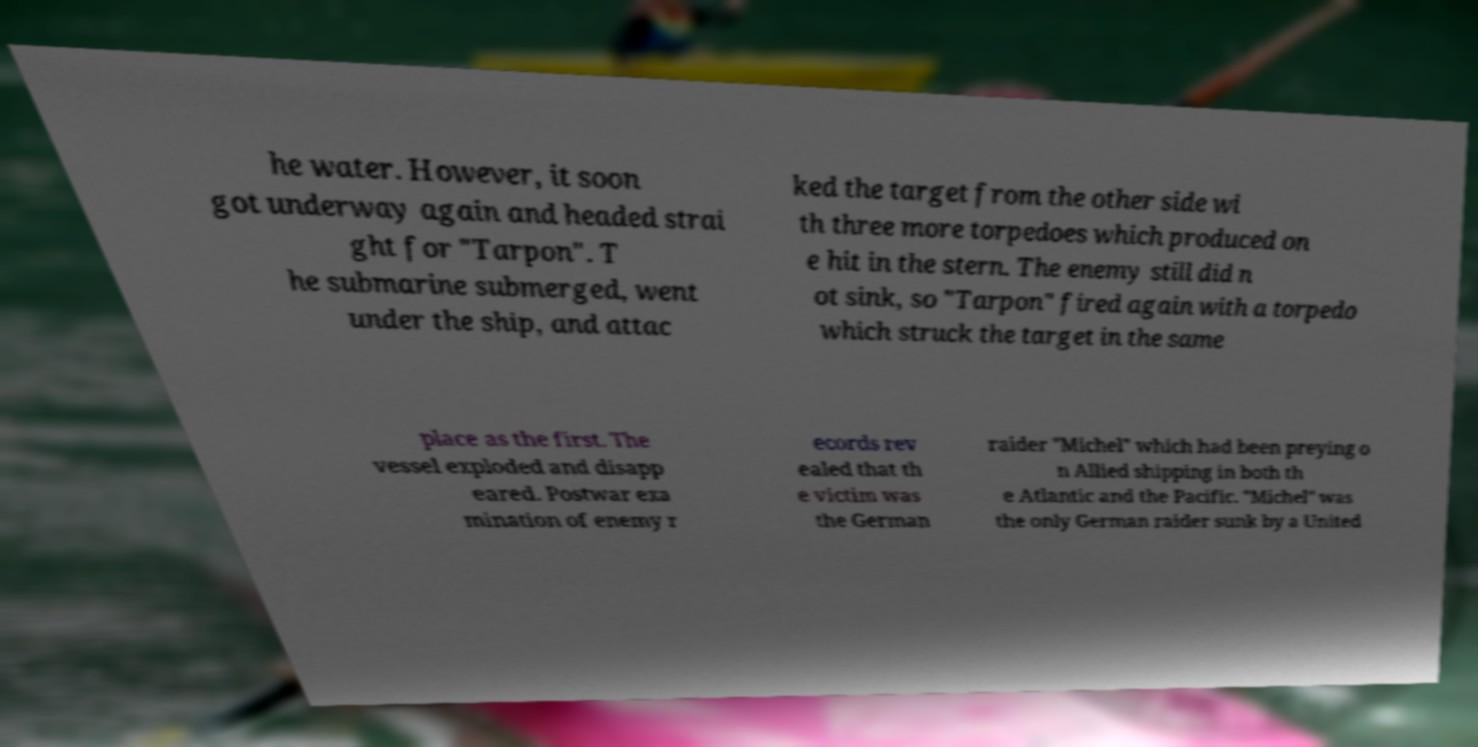Please identify and transcribe the text found in this image. he water. However, it soon got underway again and headed strai ght for "Tarpon". T he submarine submerged, went under the ship, and attac ked the target from the other side wi th three more torpedoes which produced on e hit in the stern. The enemy still did n ot sink, so "Tarpon" fired again with a torpedo which struck the target in the same place as the first. The vessel exploded and disapp eared. Postwar exa mination of enemy r ecords rev ealed that th e victim was the German raider "Michel" which had been preying o n Allied shipping in both th e Atlantic and the Pacific. "Michel" was the only German raider sunk by a United 